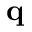Convert formula to latex. <formula><loc_0><loc_0><loc_500><loc_500>q</formula> 